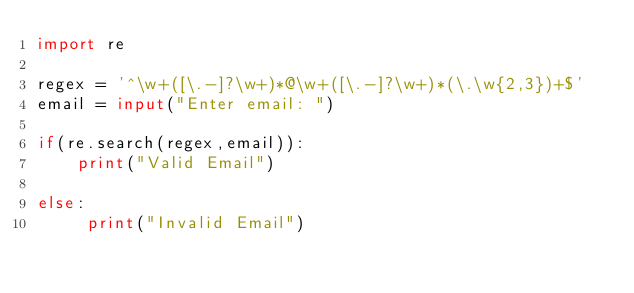<code> <loc_0><loc_0><loc_500><loc_500><_Python_>import re 

regex = '^\w+([\.-]?\w+)*@\w+([\.-]?\w+)*(\.\w{2,3})+$'
email = input("Enter email: ")

if(re.search(regex,email)):  
    print("Valid Email")  
          
else:  
     print("Invalid Email")  
    </code> 